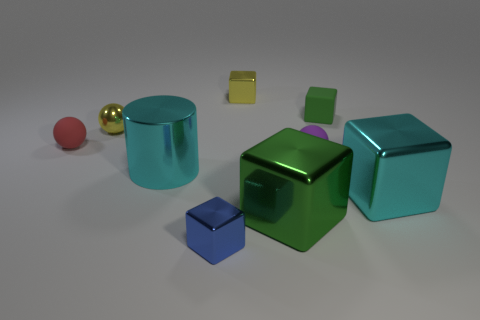What color is the tiny sphere that is the same material as the yellow block?
Keep it short and to the point. Yellow. How many objects are either cubes that are behind the cylinder or purple matte balls?
Provide a short and direct response. 3. How big is the green block that is in front of the tiny purple sphere?
Give a very brief answer. Large. There is a cyan metallic cube; is it the same size as the rubber sphere that is on the left side of the blue shiny object?
Your answer should be very brief. No. What is the color of the matte thing that is left of the rubber sphere to the right of the tiny red sphere?
Provide a succinct answer. Red. How many other objects are the same color as the metal cylinder?
Keep it short and to the point. 1. What size is the green metallic cube?
Your response must be concise. Large. Are there more tiny purple balls in front of the green metallic cube than tiny green matte objects behind the small blue block?
Your answer should be compact. No. How many small balls are to the left of the tiny matte ball that is in front of the red sphere?
Ensure brevity in your answer.  2. Does the cyan shiny object left of the blue metallic object have the same shape as the green rubber object?
Your answer should be very brief. No. 